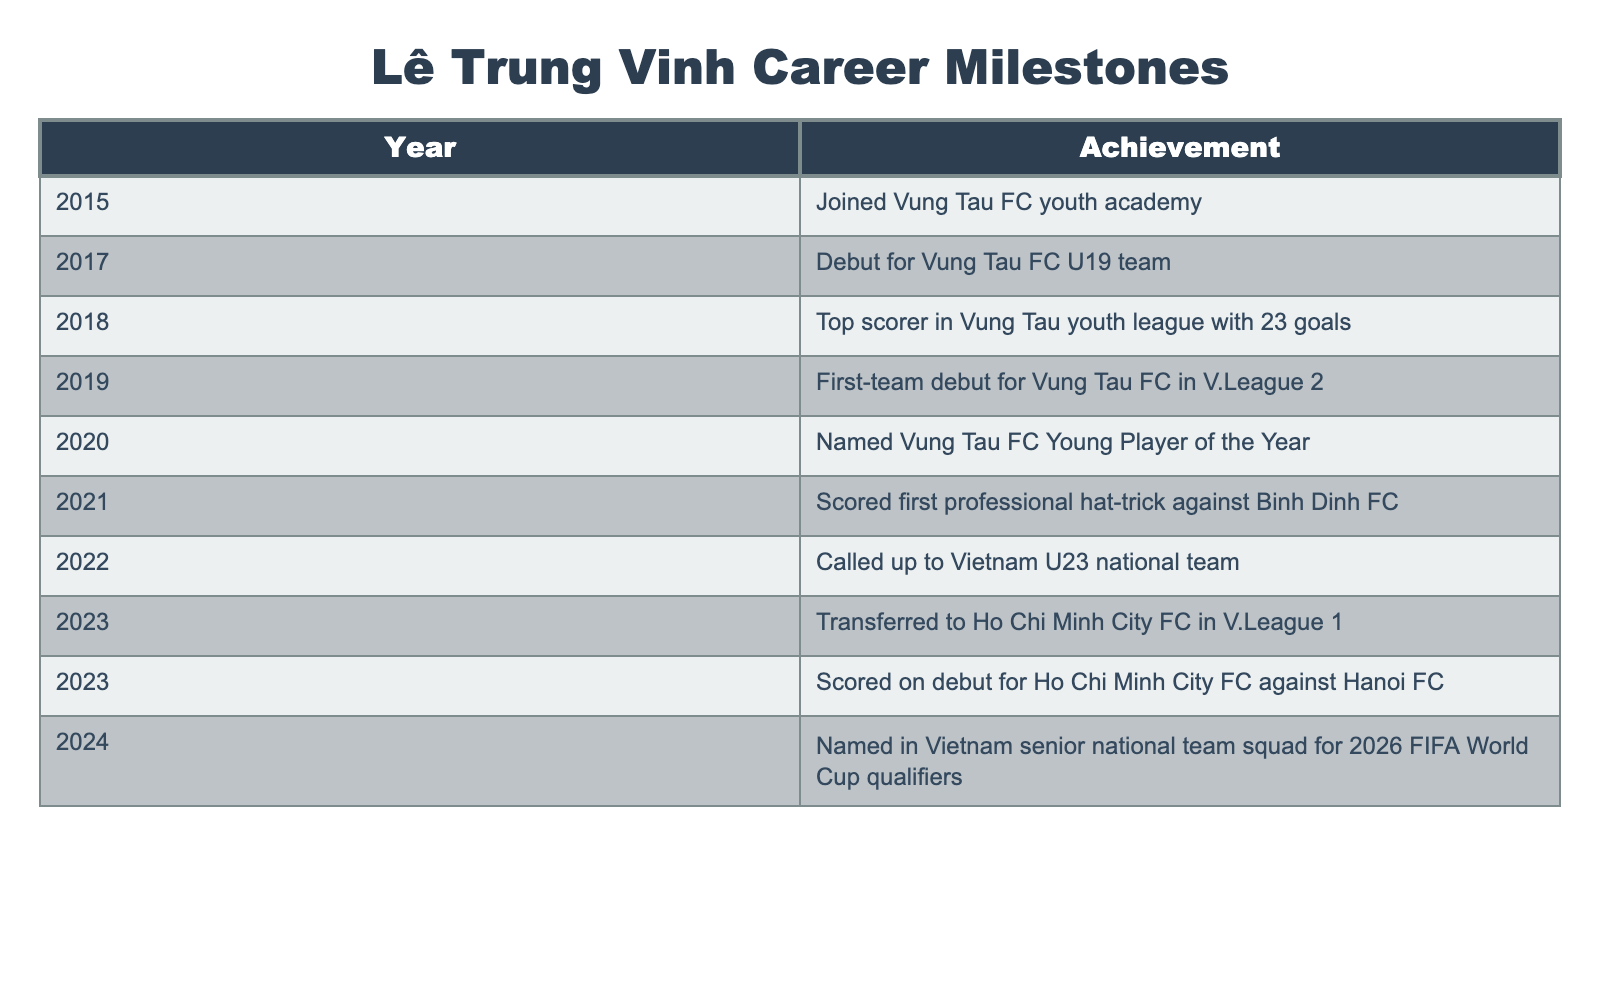What year did Lê Trung Vinh join Vung Tau FC youth academy? According to the table, Lê Trung Vinh joined the Vung Tau FC youth academy in 2015.
Answer: 2015 How many goals did Lê Trung Vinh score to become the top scorer in the Vung Tau youth league? The table states that he scored 23 goals to become the top scorer in the Vung Tau youth league in 2018.
Answer: 23 goals In which year did Lê Trung Vinh make his first-team debut for Vung Tau FC? The table indicates that he made his first-team debut for Vung Tau FC in V.League 2 in 2019.
Answer: 2019 What was Lê Trung Vinh named in 2020? The table notes that in 2020, he was named Vung Tau FC Young Player of the Year.
Answer: Young Player of the Year Did Lê Trung Vinh score on his debut for Ho Chi Minh City FC? The table confirms that he scored on his debut for Ho Chi Minh City FC against Hanoi FC in 2023.
Answer: Yes How many years passed between Lê Trung Vinh's debut for the U19 team and his transfer to Ho Chi Minh City FC? Lê Trung Vinh debuted for the Vung Tau FC U19 team in 2017 and transferred to Ho Chi Minh City FC in 2023. The gap between these two years is 6 years (2023 - 2017).
Answer: 6 years Which achievement came first, scoring a hat-trick against Binh Dinh FC or being called up to the Vietnam U23 national team? He scored his first professional hat-trick against Binh Dinh FC in 2021 and was called up to the Vietnam U23 national team in 2022. Therefore, scoring a hat-trick occurred first.
Answer: Hat-trick How many achievements did Lê Trung Vinh achieve between 2018 and 2021? From the table, the achievements between 2018 and 2021 are: top scorer in 2018, first-team debut in 2019, Young Player of the Year in 2020, and hat-trick in 2021. This totals four achievements.
Answer: 4 achievements What is the last milestone achievement listed for Lê Trung Vinh? According to the table, the last milestone achievement listed for him is being named in Vietnam's senior national team squad for the 2026 FIFA World Cup qualifiers in 2024.
Answer: 2024 World Cup qualifiers Compare the year of his transfer to Ho Chi Minh City FC with the year he joined the youth academy. How many years apart are these events? He transferred to Ho Chi Minh City FC in 2023 and joined the Vung Tau FC youth academy in 2015. The difference between these two years is 8 years (2023 - 2015).
Answer: 8 years 